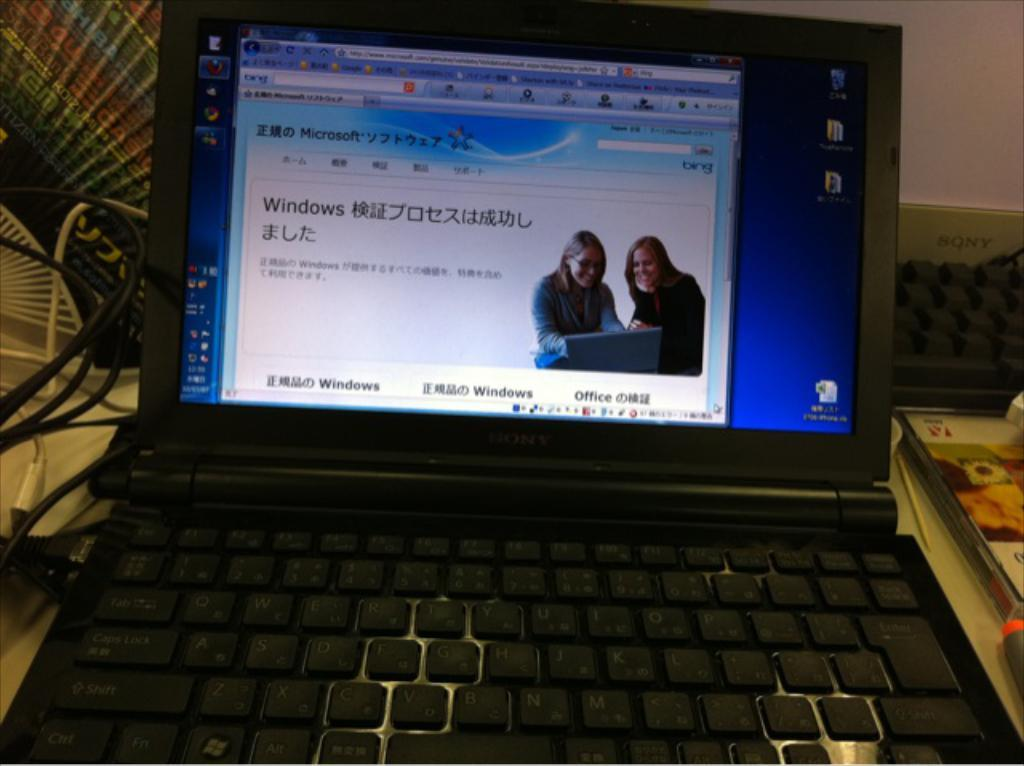<image>
Present a compact description of the photo's key features. Computer monitor showing a screen with two women and a word that says "Windows". 